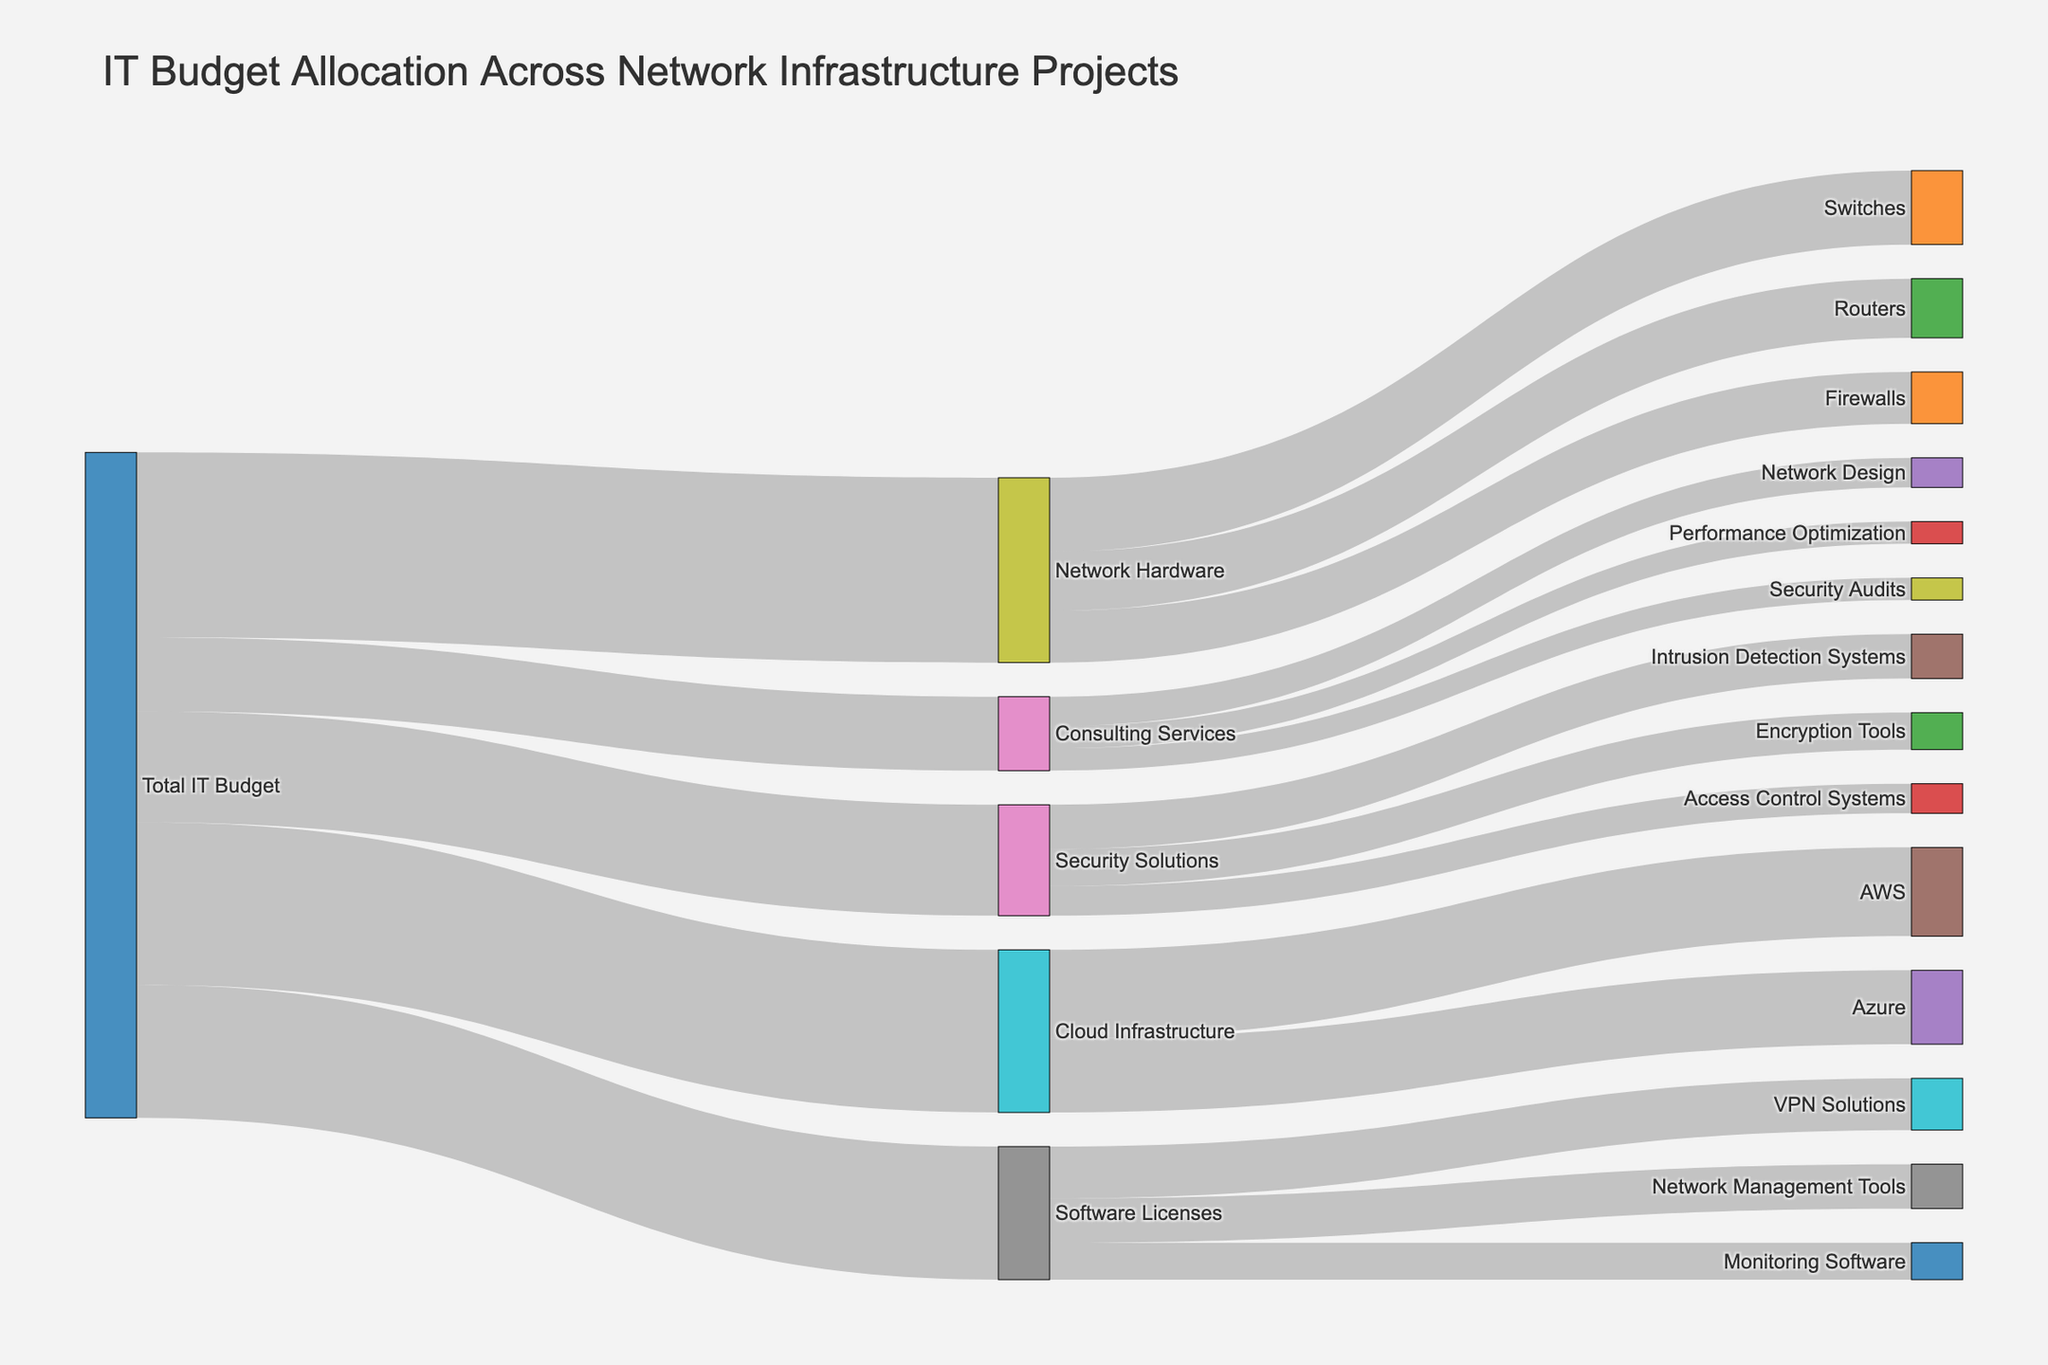What is the total budget allocated to Network Hardware? Look for the flow from 'Total IT Budget' to 'Network Hardware' and note the value.
Answer: 2500000 Which project receives the highest amount of budget allocation from 'Total IT Budget'? Compare the values flowing from 'Total IT Budget' to its immediate targets. Identify the largest value.
Answer: Network Hardware What is the combined budget for 'Network Hardware' and 'Software Licenses'? Add the budget allocated to 'Network Hardware' and 'Software Licenses' from 'Total IT Budget'.
Answer: 4300000 How does the budget allocation to 'Security Solutions' compare with that of 'Cloud Infrastructure'? Identify the values flowing to 'Security Solutions' and 'Cloud Infrastructure' from 'Total IT Budget'. Compare these values.
Answer: Cloud Infrastructure gets more What is the total budget allocated to 'Software Licenses'? Identify the value flowing from 'Total IT Budget' to 'Software Licenses'.
Answer: 1800000 What is the budget allocation for 'Routers' within 'Network Hardware'? Look for the flow from 'Network Hardware' to 'Routers' and note the value.
Answer: 800000 Which sub-category under 'Security Solutions' receives the least budget? Identify all the sub-categories under 'Security Solutions' and compare their budget allocations to find the smallest value.
Answer: Access Control Systems What is the total budget allocated to 'Consulting Services'? Add up the values flowing to all sub-categories under 'Consulting Services'.
Answer: 1000000 Which has a higher budget allocation, 'Performance Optimization' or 'Monitoring Software'? Compare the values for 'Performance Optimization' and 'Monitoring Software' by identifying their flows.
Answer: Monitoring Software How does the budget allocation to 'AWS' compare with that to 'Azure' within 'Cloud Infrastructure'? Look for the flows from 'Cloud Infrastructure' to 'AWS' and 'Azure', then compare their values.
Answer: AWS gets more 